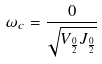Convert formula to latex. <formula><loc_0><loc_0><loc_500><loc_500>\omega _ { c } = \frac { 0 } { \sqrt { V _ { \frac { 0 } { 2 } } J _ { \frac { 0 } { 2 } } } }</formula> 